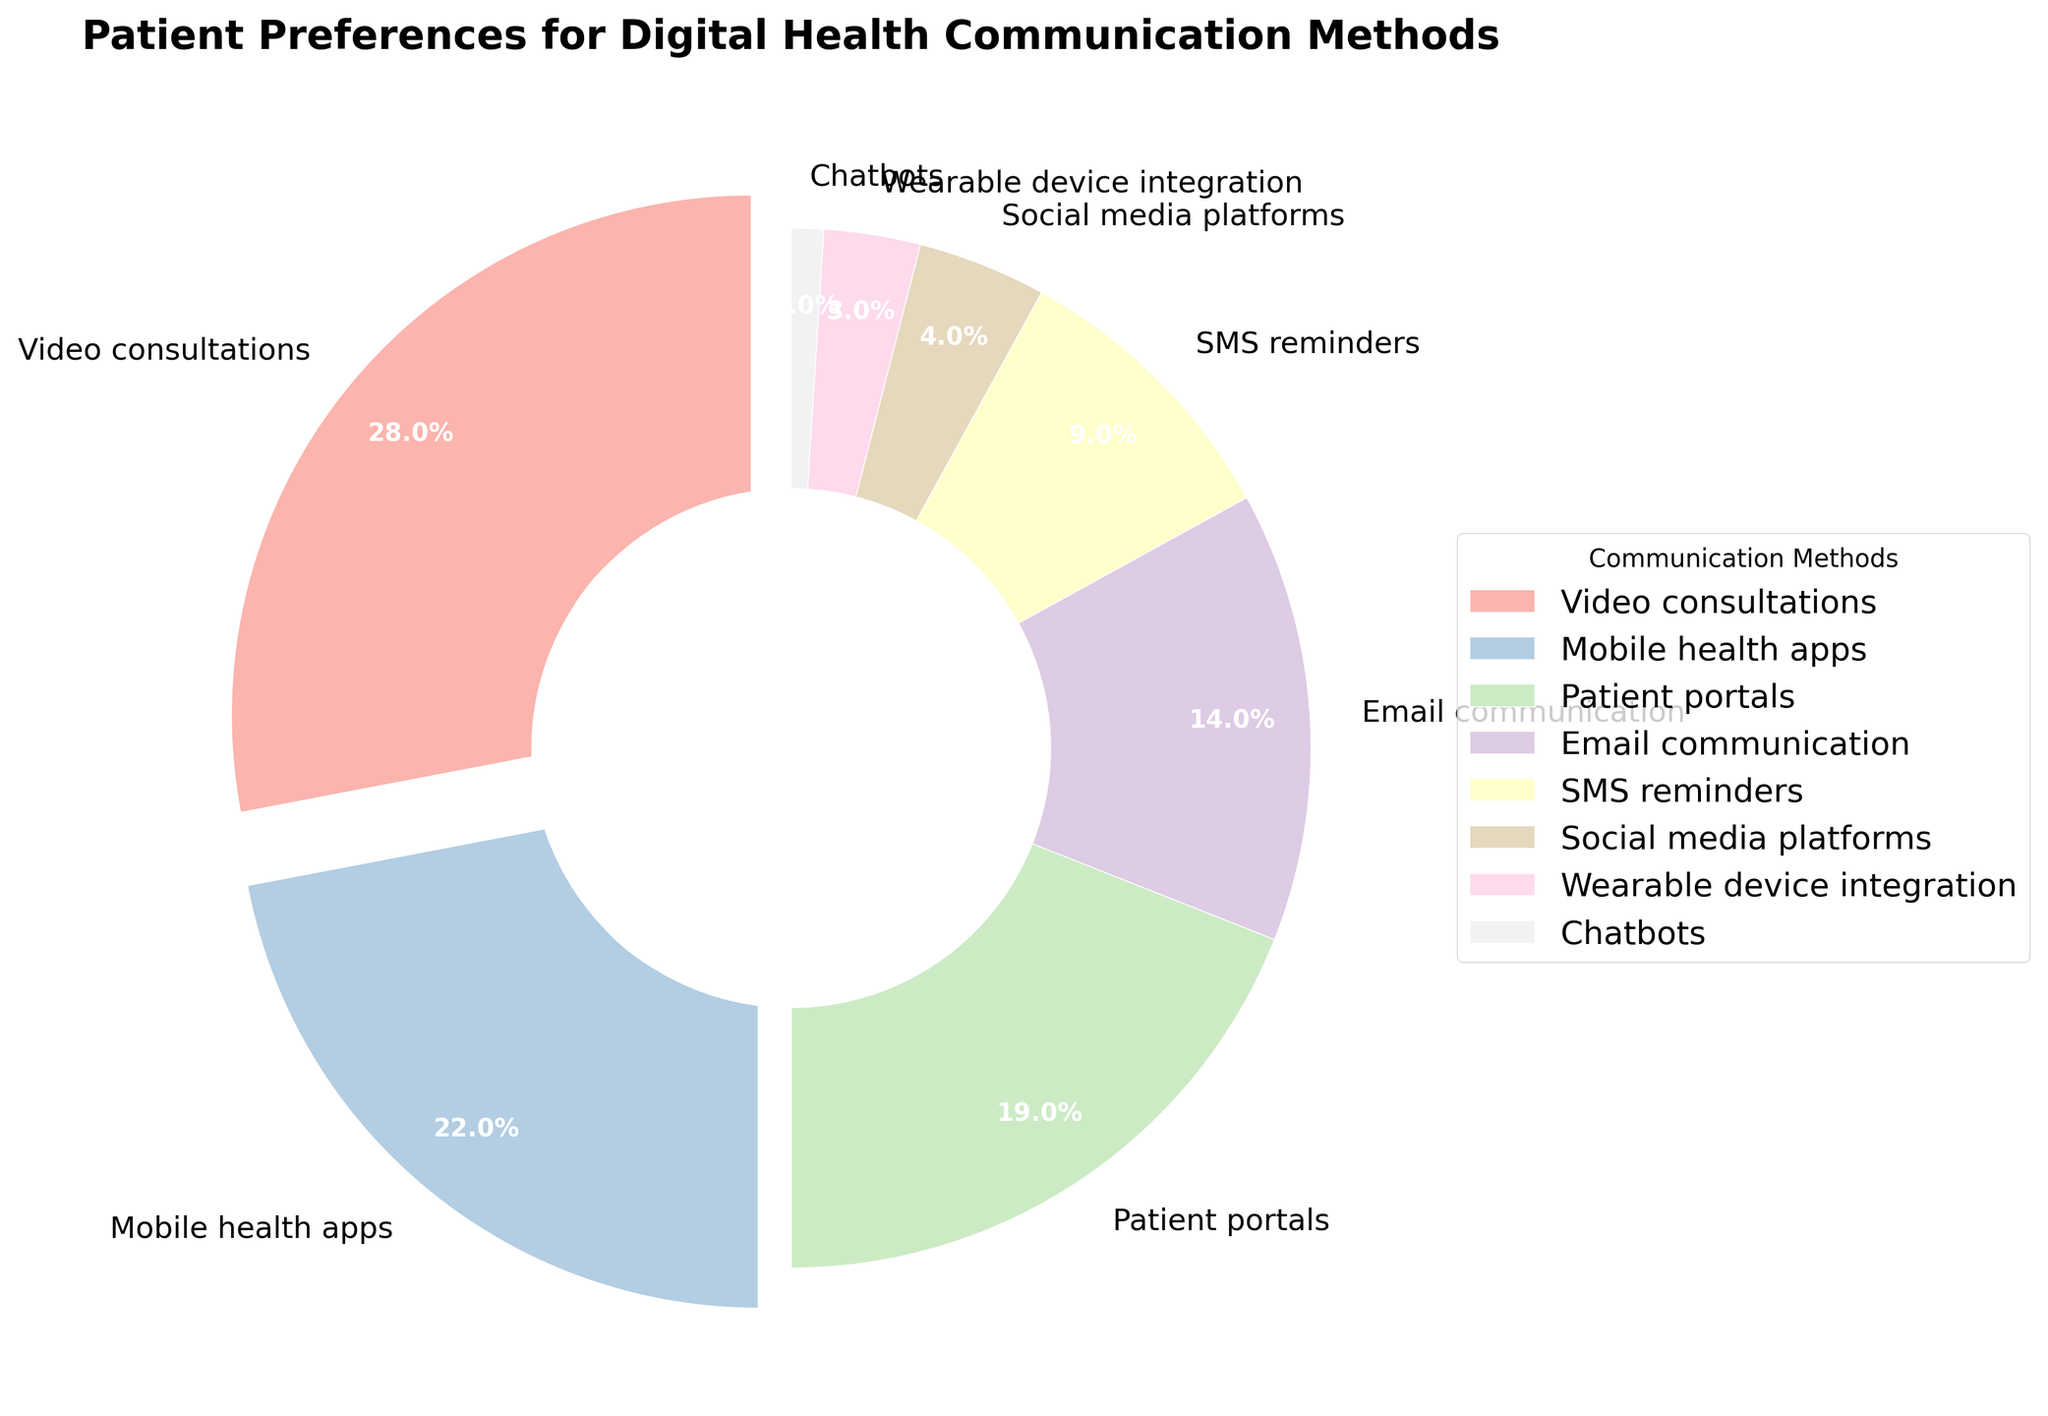what are the two most preferred communication methods among patients? The two largest segments in the pie chart represent the two most preferred methods. Video consultations have the largest percentage at 28%. The second largest segment is Mobile health apps at 22%.
Answer: Video consultations and Mobile health apps What is the combined percentage preference for Email communication and SMS reminders? The percentage for Email communication is 14%, and for SMS reminders, it is 9%. Adding these two percentages together gives 14% + 9% = 23%.
Answer: 23% Which communication method has the lowest preference among patients? The smallest segment of the pie chart represents the least preferred method. Chatbots have the smallest percentage at 1%.
Answer: Chatbots Is the percentage of patients who prefer Mobile health apps greater than those who prefer Patient portals? The percentage for Mobile health apps is 22%, while for Patient portals, it is 19%. Therefore, the percentage of patients who prefer Mobile health apps is greater than those who prefer Patient portals.
Answer: Yes What is the total preference percentage for communication methods that are not Video consultations, Mobile health apps, or Patient portals? The combined percentage for Video consultations, Mobile health apps, and Patient portals is 28% + 22% + 19% = 69%. The total preference percentage is 100%, so subtracting 69% from this gives 100% - 69% = 31%.
Answer: 31% What is the average preference percentage for Wearable device integration, Chatbots, and Social media platforms? The percentages for Wearable device integration, Chatbots, and Social media platforms are 3%, 1%, and 4% respectively. Adding these gives 3% + 1% + 4% = 8%. Dividing by 3, the average percentage is 8% / 3 ≈ 2.67%.
Answer: 2.67% Out of the three most preferred communication methods, which one has the smallest wedge? The three most preferred communication methods are Video consultations, Mobile health apps, and Patient portals. Among these, Patient portals has the smallest wedge with 19%.
Answer: Patient portals 